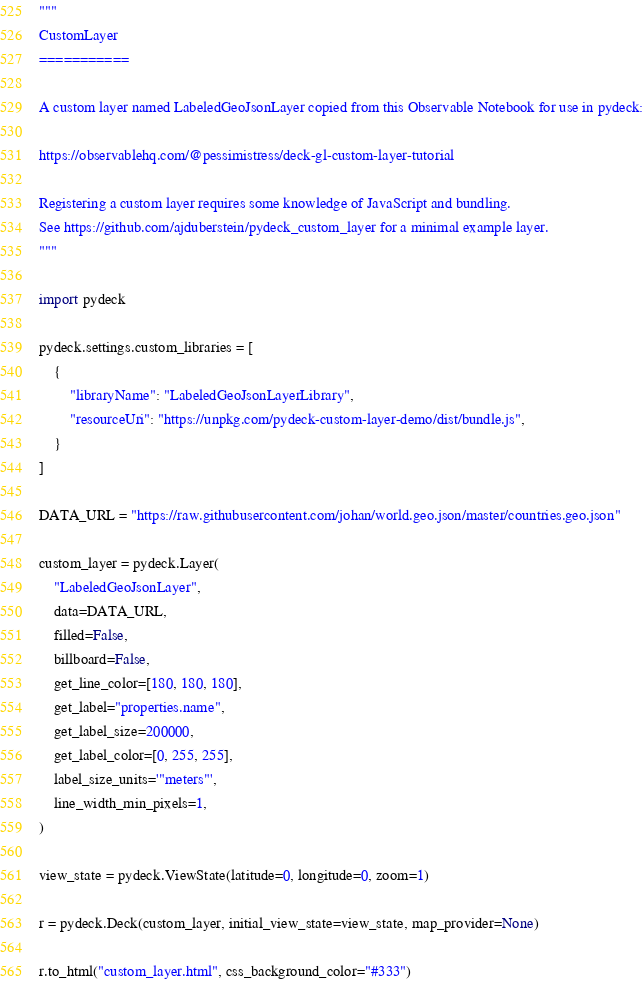Convert code to text. <code><loc_0><loc_0><loc_500><loc_500><_Python_>"""
CustomLayer
===========

A custom layer named LabeledGeoJsonLayer copied from this Observable Notebook for use in pydeck:

https://observablehq.com/@pessimistress/deck-gl-custom-layer-tutorial

Registering a custom layer requires some knowledge of JavaScript and bundling.
See https://github.com/ajduberstein/pydeck_custom_layer for a minimal example layer.
"""

import pydeck

pydeck.settings.custom_libraries = [
    {
        "libraryName": "LabeledGeoJsonLayerLibrary",
        "resourceUri": "https://unpkg.com/pydeck-custom-layer-demo/dist/bundle.js",
    }
]

DATA_URL = "https://raw.githubusercontent.com/johan/world.geo.json/master/countries.geo.json"

custom_layer = pydeck.Layer(
    "LabeledGeoJsonLayer",
    data=DATA_URL,
    filled=False,
    billboard=False,
    get_line_color=[180, 180, 180],
    get_label="properties.name",
    get_label_size=200000,
    get_label_color=[0, 255, 255],
    label_size_units='"meters"',
    line_width_min_pixels=1,
)

view_state = pydeck.ViewState(latitude=0, longitude=0, zoom=1)

r = pydeck.Deck(custom_layer, initial_view_state=view_state, map_provider=None)

r.to_html("custom_layer.html", css_background_color="#333")
</code> 